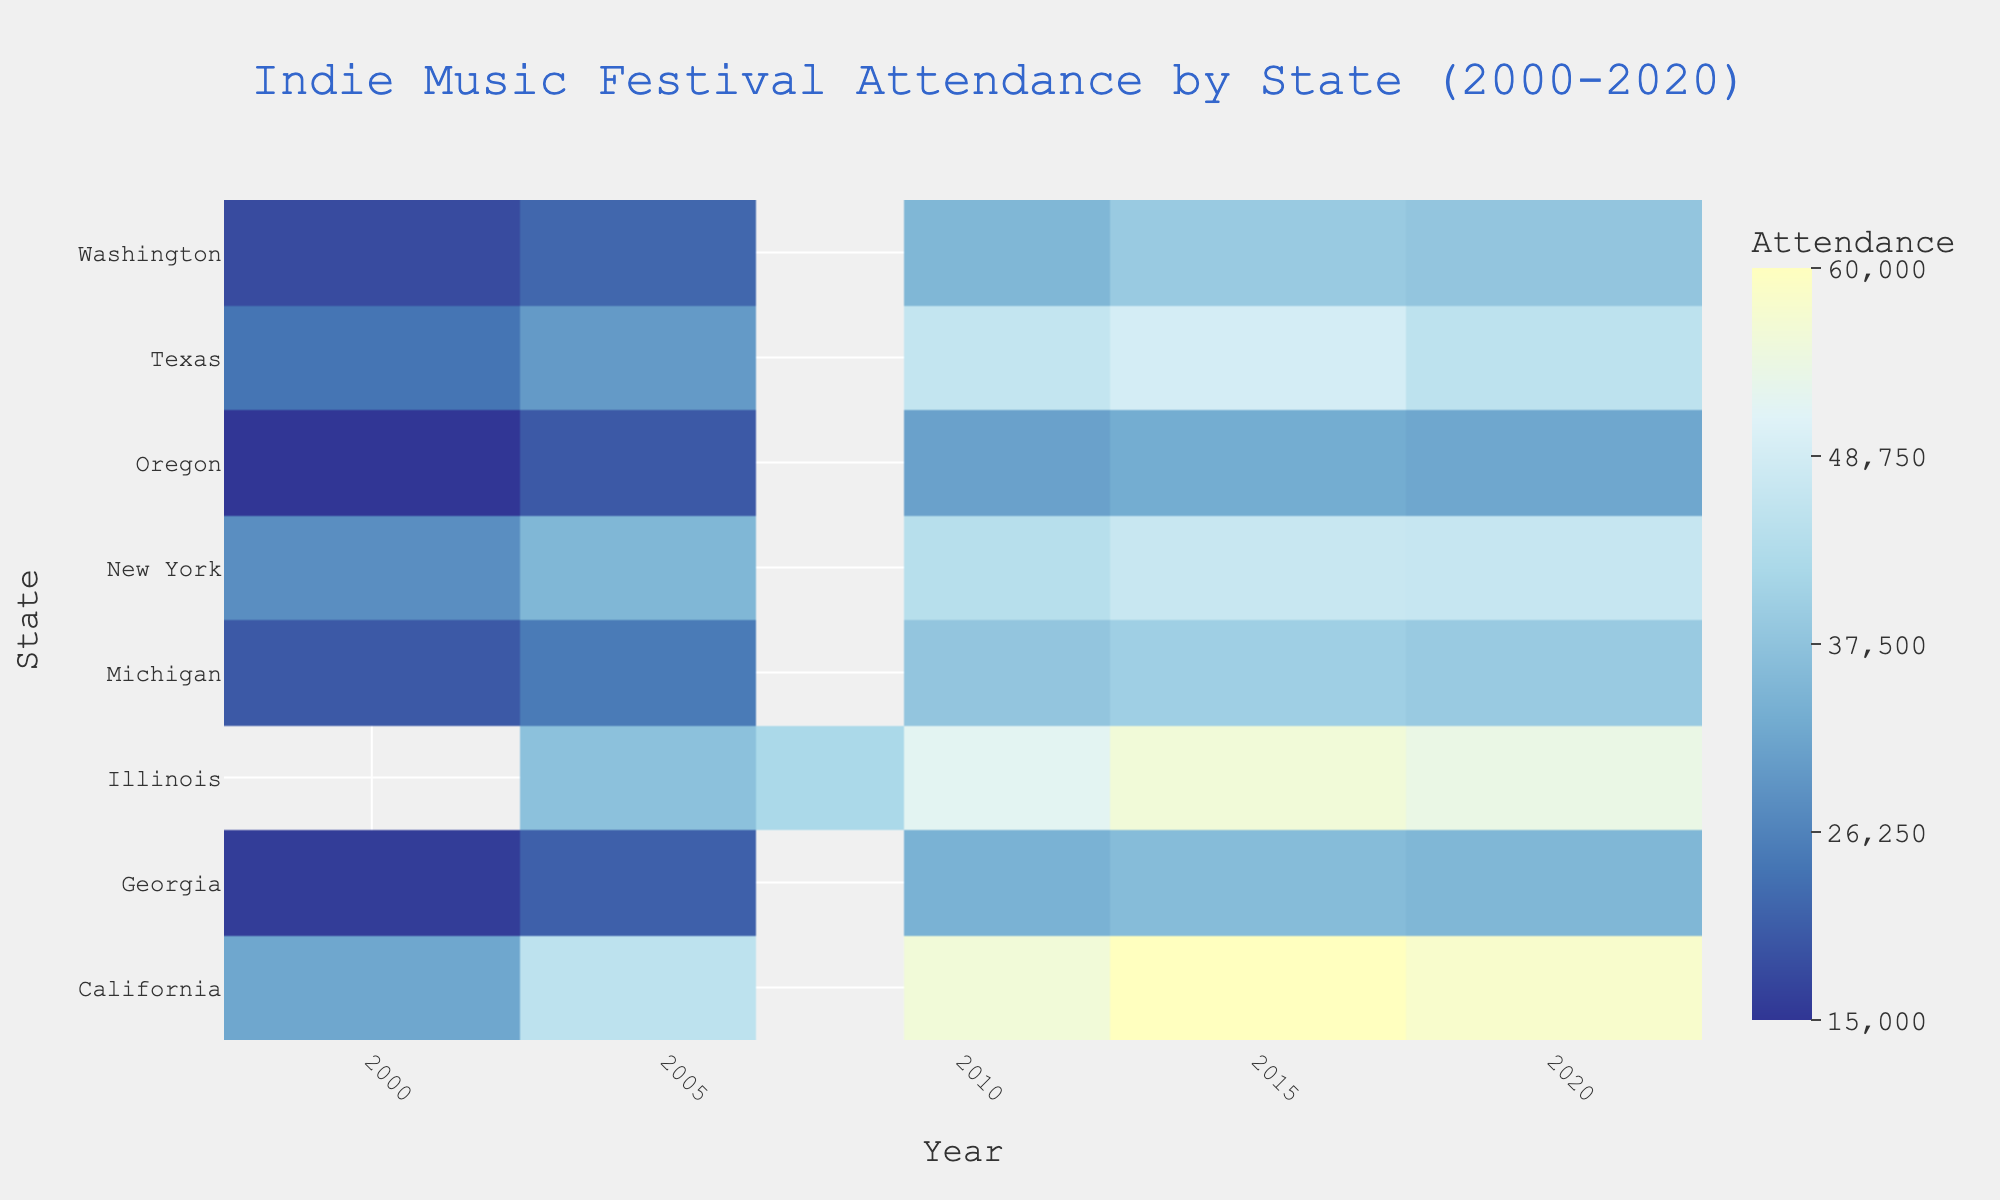What state had the highest attendance in 2020? Look at the year 2020 column and find the highest value. The state corresponding to the highest value is California with 58,000.
Answer: California How did the attendance in Illinois change from 2008 to 2020? Find the attendance values for Illinois in 2008 (42,000) and 2020 (54,000). Calculate the difference: 54,000 - 42,000 = 12,000 increase.
Answer: Increased by 12,000 Which state experienced the largest increase in attendance from 2000 to 2010? Calculate the difference in attendance for each state between 2000 and 2010. The state with the largest positive change is Texas (46,000 - 24,000 = 22,000 increase).
Answer: Texas What is the average festival attendance in New York across all years? Sum the attendance values for New York (28,000 + 35,000 + 44,000 + 47,000 + 46,500) and divide by 5. Average = 200,500 / 5 = 40,100.
Answer: 40,100 In which year did Michigan have its highest festival attendance? Look at the row for Michigan and find the highest value. The highest value is 40,000 in the year 2015.
Answer: 2015 How does California's 2015 attendance compare to New York’s 2015 attendance? Refer to the 2015 attendance for both states: California (60,000) and New York (47,000). California's attendance is greater by 13,000.
Answer: California's is greater by 13,000 Which state had the lowest attendance in 2000, and what was the value? Look at the year 2000 column and find the lowest value. Oregon had the lowest attendance with 15,000.
Answer: Oregon, 15,000 What is the trend in festival attendance in Washington from 2000 to 2020? Identify the attendance values for Washington from 2000 to 2020 and describe the trend. Values are 18,000, 22,000, 35,000, 39,000, 38,000. The attendance generally increased over the years.
Answer: Increasing trend Determine the total festival attendance across all states in 2010. Sum the attendance values for all states in 2010: 56,000 (CA) + 44,000 (NY) + 52,000 (IL) + 46,000 (TX) + 35,000 (WA) + 31,000 (OR) + 38,000 (MI) + 34,000 (GA). Total = 336,000.
Answer: 336,000 Compare the trend of festival attendance in Georgia and Oregon from 2000 to 2020. Identify the values for Georgia (16,000, 21,000, 34,000, 36,000, 35,000) and Oregon (15,000, 20,000, 31,000, 33,000, 32,000). Both states show an increasing trend over the years but Georgia had a slightly higher overall growth.
Answer: Both increasing, Georgia slightly higher growth 